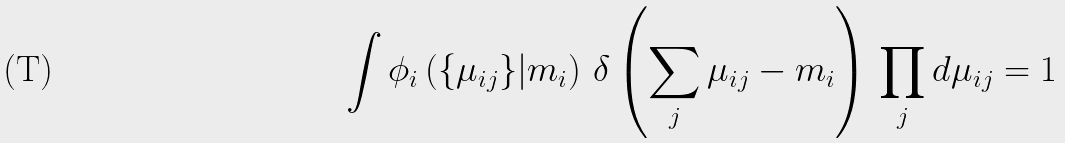Convert formula to latex. <formula><loc_0><loc_0><loc_500><loc_500>\int \phi _ { i } \left ( \{ \mu _ { i j } \} | m _ { i } \right ) \, \delta \left ( \sum _ { j } \mu _ { i j } - m _ { i } \right ) \, \prod _ { j } d \mu _ { i j } = 1</formula> 